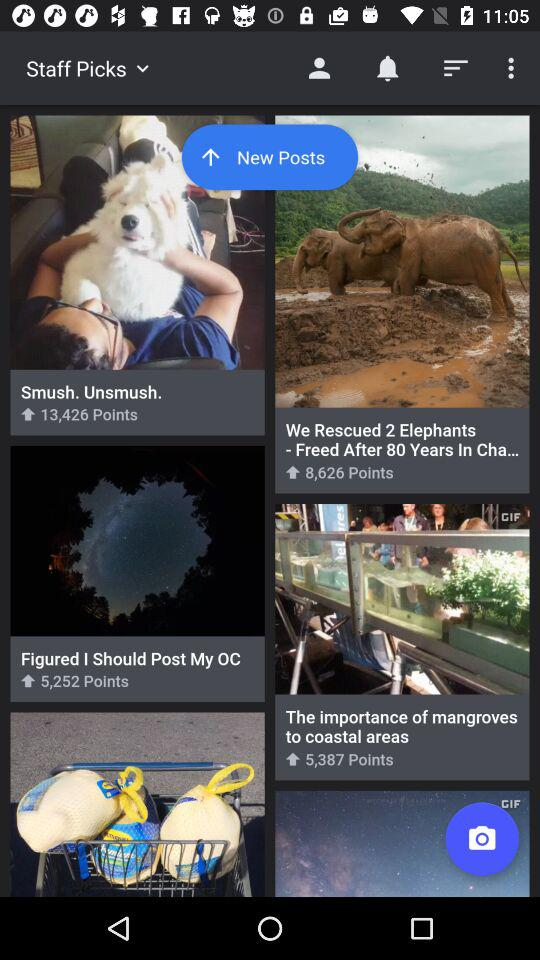How many points are shown in "Figured I Should Post My OC"? There are 5,252 points shown in "Figured I Should Post My OC". 